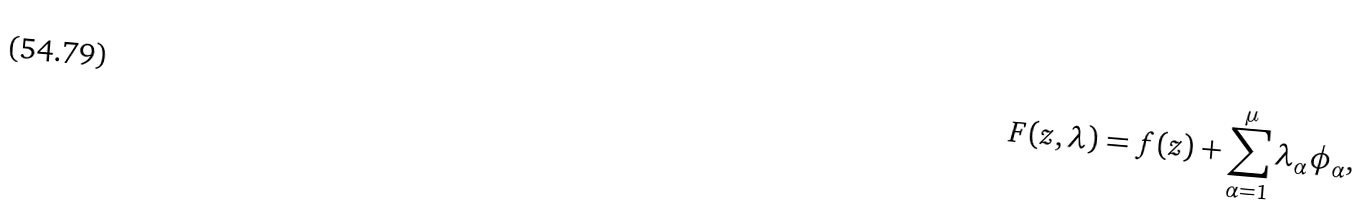<formula> <loc_0><loc_0><loc_500><loc_500>F ( z , \lambda ) = f ( z ) + \sum _ { \alpha = 1 } ^ { \mu } \lambda _ { \alpha } \phi _ { \alpha } ,</formula> 